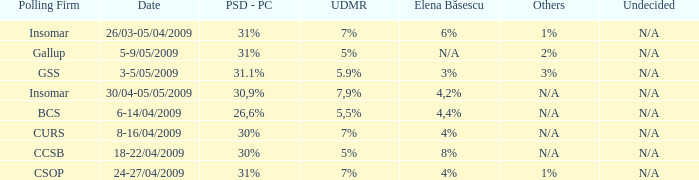What was the UDMR for 18-22/04/2009? 5%. 